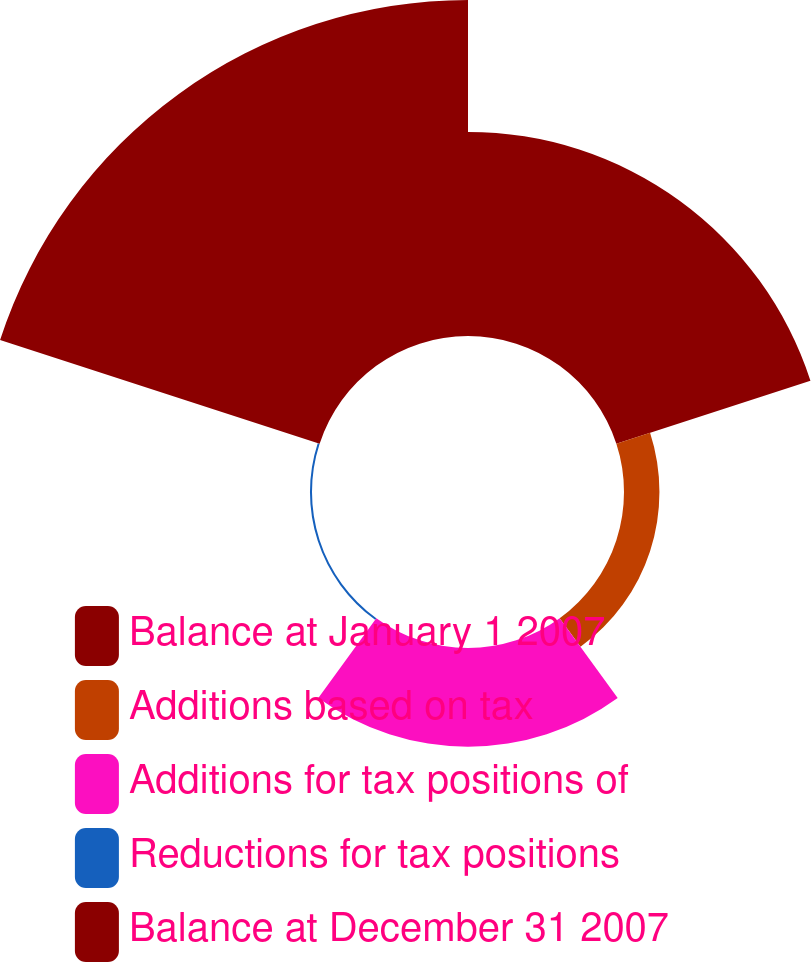Convert chart. <chart><loc_0><loc_0><loc_500><loc_500><pie_chart><fcel>Balance at January 1 2007<fcel>Additions based on tax<fcel>Additions for tax positions of<fcel>Reductions for tax positions<fcel>Balance at December 31 2007<nl><fcel>30.18%<fcel>5.24%<fcel>14.59%<fcel>0.3%<fcel>49.69%<nl></chart> 